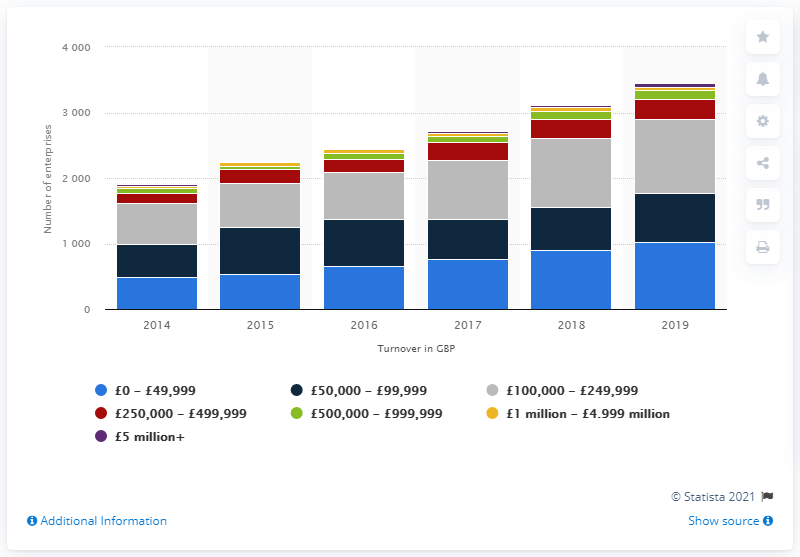Outline some significant characteristics in this image. In 2018, it was estimated that 25 fitness enterprises were in operation in the UK. 